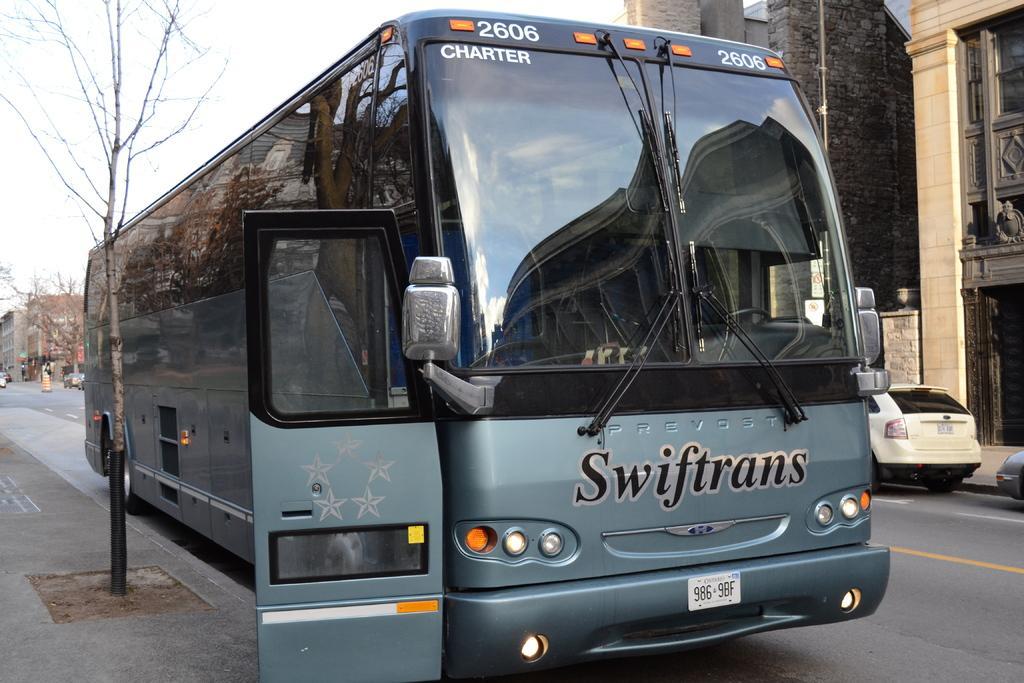Please provide a concise description of this image. In this image in the middle, there is a bus. On the left there is a tree. On the right there are cars, buildings and road. In the background there are buildings, cars, some people and sky. 